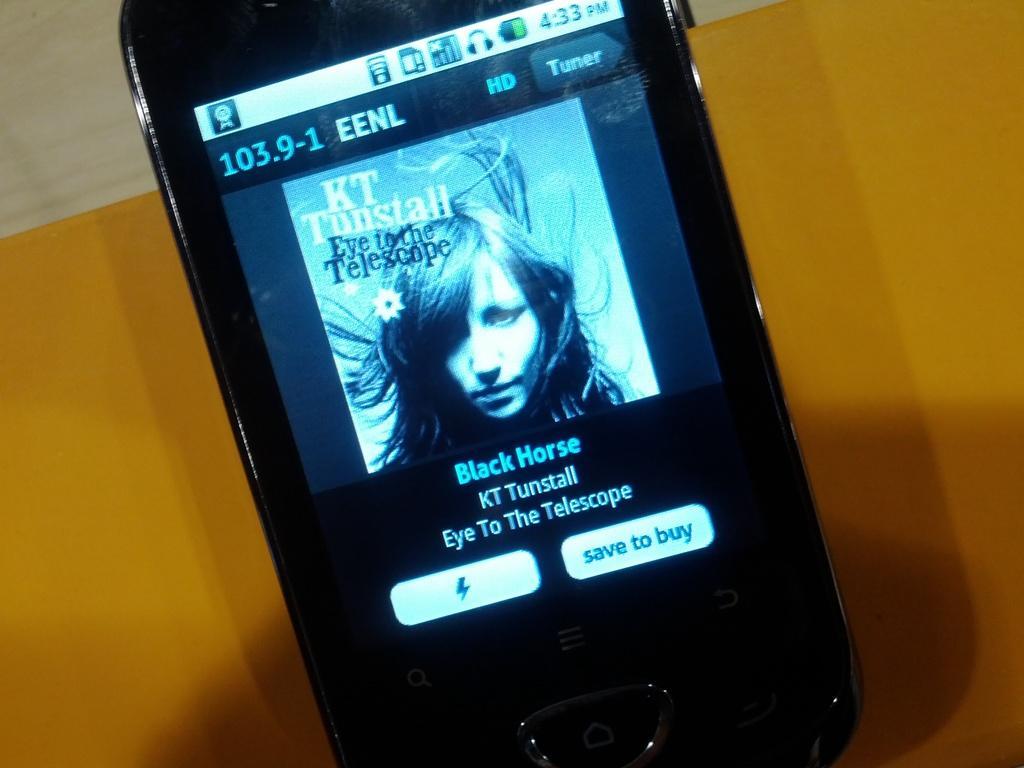Can you describe this image briefly? In this picture, we see a mobile phone which is displaying some text and it is also displaying the image of the woman. In the background, it is yellow in color and it might be a table. In the left top, it is white in color and it might be a wall. 